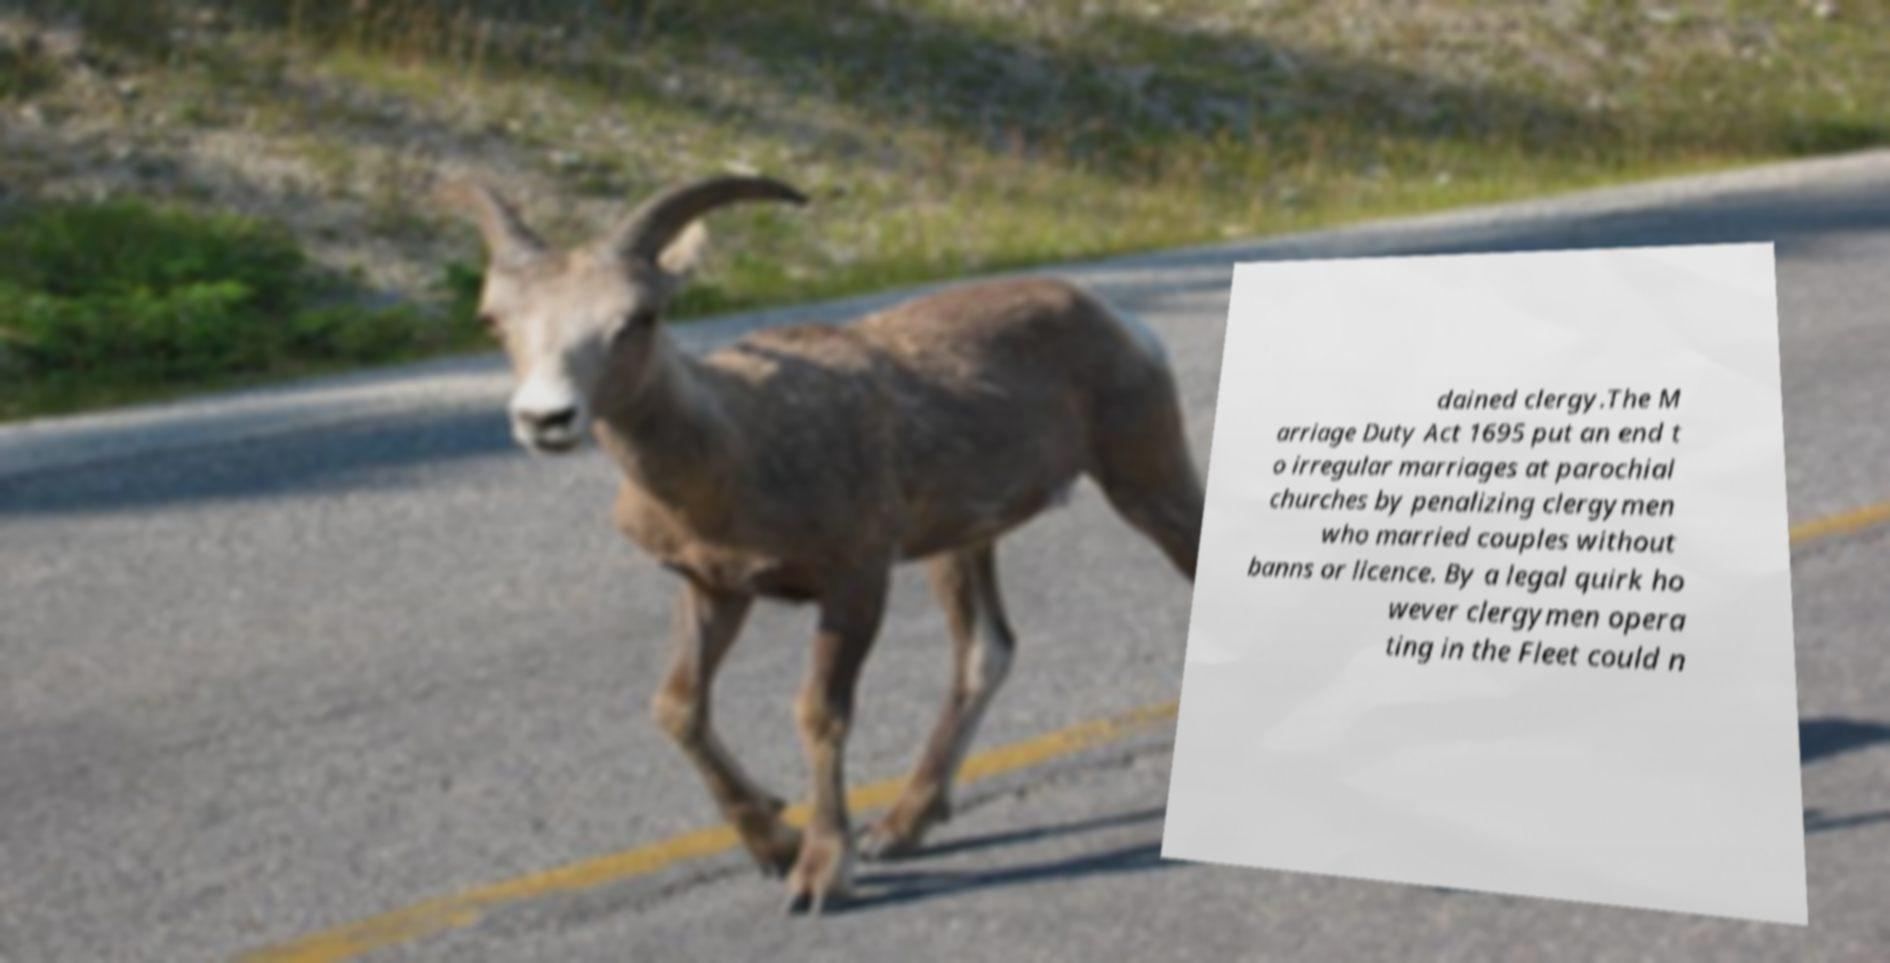Can you read and provide the text displayed in the image?This photo seems to have some interesting text. Can you extract and type it out for me? dained clergy.The M arriage Duty Act 1695 put an end t o irregular marriages at parochial churches by penalizing clergymen who married couples without banns or licence. By a legal quirk ho wever clergymen opera ting in the Fleet could n 